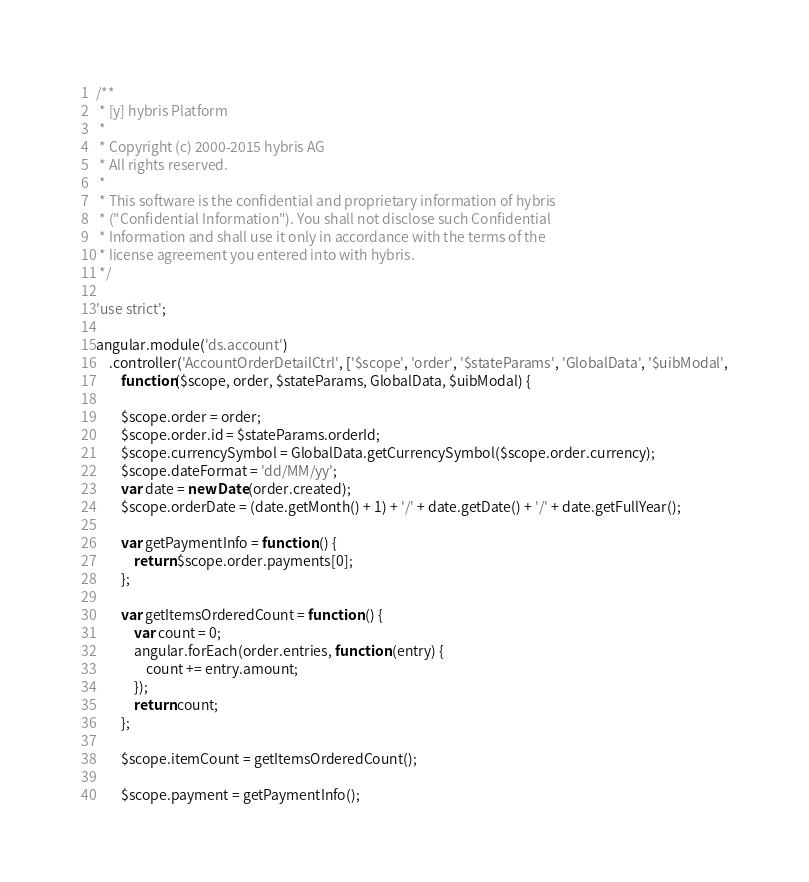Convert code to text. <code><loc_0><loc_0><loc_500><loc_500><_JavaScript_>/**
 * [y] hybris Platform
 *
 * Copyright (c) 2000-2015 hybris AG
 * All rights reserved.
 *
 * This software is the confidential and proprietary information of hybris
 * ("Confidential Information"). You shall not disclose such Confidential
 * Information and shall use it only in accordance with the terms of the
 * license agreement you entered into with hybris.
 */

'use strict';

angular.module('ds.account')
    .controller('AccountOrderDetailCtrl', ['$scope', 'order', '$stateParams', 'GlobalData', '$uibModal',
        function($scope, order, $stateParams, GlobalData, $uibModal) {

        $scope.order = order;
        $scope.order.id = $stateParams.orderId;
        $scope.currencySymbol = GlobalData.getCurrencySymbol($scope.order.currency);
        $scope.dateFormat = 'dd/MM/yy';
        var date = new Date(order.created);
        $scope.orderDate = (date.getMonth() + 1) + '/' + date.getDate() + '/' + date.getFullYear();
        
        var getPaymentInfo = function () {
            return $scope.order.payments[0];
        };

        var getItemsOrderedCount = function () {
            var count = 0;
            angular.forEach(order.entries, function (entry) {
                count += entry.amount;
            });
            return count;
        };

        $scope.itemCount = getItemsOrderedCount();

        $scope.payment = getPaymentInfo();
</code> 